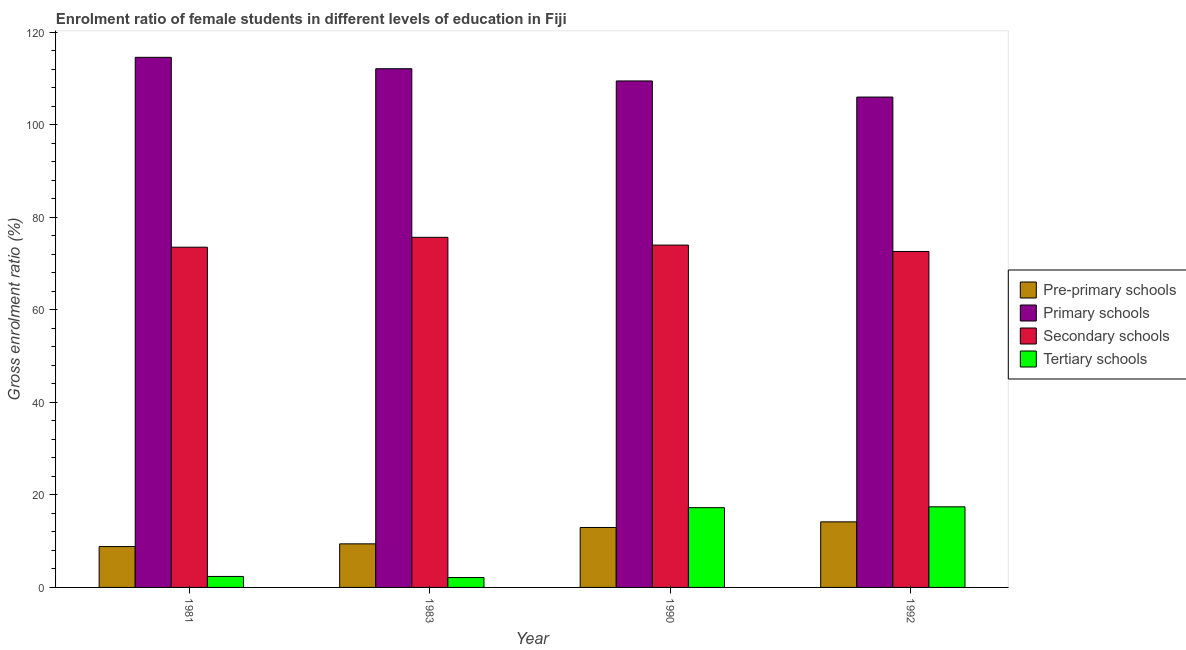How many groups of bars are there?
Your response must be concise. 4. Are the number of bars per tick equal to the number of legend labels?
Ensure brevity in your answer.  Yes. Are the number of bars on each tick of the X-axis equal?
Provide a short and direct response. Yes. How many bars are there on the 3rd tick from the left?
Provide a short and direct response. 4. How many bars are there on the 2nd tick from the right?
Ensure brevity in your answer.  4. In how many cases, is the number of bars for a given year not equal to the number of legend labels?
Your response must be concise. 0. What is the gross enrolment ratio(male) in primary schools in 1983?
Keep it short and to the point. 112.1. Across all years, what is the maximum gross enrolment ratio(male) in secondary schools?
Make the answer very short. 75.66. Across all years, what is the minimum gross enrolment ratio(male) in secondary schools?
Make the answer very short. 72.61. In which year was the gross enrolment ratio(male) in tertiary schools minimum?
Provide a succinct answer. 1983. What is the total gross enrolment ratio(male) in primary schools in the graph?
Provide a succinct answer. 442.09. What is the difference between the gross enrolment ratio(male) in tertiary schools in 1983 and that in 1990?
Offer a terse response. -15.1. What is the difference between the gross enrolment ratio(male) in secondary schools in 1981 and the gross enrolment ratio(male) in tertiary schools in 1983?
Offer a terse response. -2.13. What is the average gross enrolment ratio(male) in tertiary schools per year?
Provide a short and direct response. 9.79. In how many years, is the gross enrolment ratio(male) in secondary schools greater than 108 %?
Make the answer very short. 0. What is the ratio of the gross enrolment ratio(male) in pre-primary schools in 1983 to that in 1990?
Provide a succinct answer. 0.73. Is the gross enrolment ratio(male) in secondary schools in 1981 less than that in 1983?
Provide a succinct answer. Yes. Is the difference between the gross enrolment ratio(male) in secondary schools in 1981 and 1983 greater than the difference between the gross enrolment ratio(male) in tertiary schools in 1981 and 1983?
Your answer should be compact. No. What is the difference between the highest and the second highest gross enrolment ratio(male) in tertiary schools?
Offer a very short reply. 0.19. What is the difference between the highest and the lowest gross enrolment ratio(male) in tertiary schools?
Your answer should be compact. 15.29. In how many years, is the gross enrolment ratio(male) in primary schools greater than the average gross enrolment ratio(male) in primary schools taken over all years?
Offer a terse response. 2. Is the sum of the gross enrolment ratio(male) in pre-primary schools in 1981 and 1983 greater than the maximum gross enrolment ratio(male) in tertiary schools across all years?
Offer a terse response. Yes. What does the 1st bar from the left in 1981 represents?
Give a very brief answer. Pre-primary schools. What does the 4th bar from the right in 1981 represents?
Keep it short and to the point. Pre-primary schools. Is it the case that in every year, the sum of the gross enrolment ratio(male) in pre-primary schools and gross enrolment ratio(male) in primary schools is greater than the gross enrolment ratio(male) in secondary schools?
Ensure brevity in your answer.  Yes. How many years are there in the graph?
Ensure brevity in your answer.  4. Are the values on the major ticks of Y-axis written in scientific E-notation?
Give a very brief answer. No. Does the graph contain any zero values?
Offer a very short reply. No. How are the legend labels stacked?
Offer a very short reply. Vertical. What is the title of the graph?
Make the answer very short. Enrolment ratio of female students in different levels of education in Fiji. What is the label or title of the X-axis?
Your answer should be compact. Year. What is the Gross enrolment ratio (%) in Pre-primary schools in 1981?
Your response must be concise. 8.83. What is the Gross enrolment ratio (%) of Primary schools in 1981?
Provide a succinct answer. 114.56. What is the Gross enrolment ratio (%) of Secondary schools in 1981?
Make the answer very short. 73.53. What is the Gross enrolment ratio (%) in Tertiary schools in 1981?
Provide a short and direct response. 2.37. What is the Gross enrolment ratio (%) of Pre-primary schools in 1983?
Your answer should be compact. 9.42. What is the Gross enrolment ratio (%) in Primary schools in 1983?
Offer a very short reply. 112.1. What is the Gross enrolment ratio (%) in Secondary schools in 1983?
Provide a short and direct response. 75.66. What is the Gross enrolment ratio (%) of Tertiary schools in 1983?
Offer a very short reply. 2.13. What is the Gross enrolment ratio (%) of Pre-primary schools in 1990?
Give a very brief answer. 12.96. What is the Gross enrolment ratio (%) in Primary schools in 1990?
Make the answer very short. 109.46. What is the Gross enrolment ratio (%) of Secondary schools in 1990?
Offer a terse response. 73.99. What is the Gross enrolment ratio (%) in Tertiary schools in 1990?
Your answer should be very brief. 17.23. What is the Gross enrolment ratio (%) of Pre-primary schools in 1992?
Give a very brief answer. 14.17. What is the Gross enrolment ratio (%) in Primary schools in 1992?
Offer a very short reply. 105.98. What is the Gross enrolment ratio (%) in Secondary schools in 1992?
Make the answer very short. 72.61. What is the Gross enrolment ratio (%) in Tertiary schools in 1992?
Your answer should be very brief. 17.42. Across all years, what is the maximum Gross enrolment ratio (%) of Pre-primary schools?
Give a very brief answer. 14.17. Across all years, what is the maximum Gross enrolment ratio (%) in Primary schools?
Provide a short and direct response. 114.56. Across all years, what is the maximum Gross enrolment ratio (%) in Secondary schools?
Offer a very short reply. 75.66. Across all years, what is the maximum Gross enrolment ratio (%) in Tertiary schools?
Your answer should be very brief. 17.42. Across all years, what is the minimum Gross enrolment ratio (%) of Pre-primary schools?
Your response must be concise. 8.83. Across all years, what is the minimum Gross enrolment ratio (%) of Primary schools?
Provide a short and direct response. 105.98. Across all years, what is the minimum Gross enrolment ratio (%) in Secondary schools?
Offer a very short reply. 72.61. Across all years, what is the minimum Gross enrolment ratio (%) in Tertiary schools?
Your answer should be very brief. 2.13. What is the total Gross enrolment ratio (%) of Pre-primary schools in the graph?
Offer a very short reply. 45.37. What is the total Gross enrolment ratio (%) in Primary schools in the graph?
Give a very brief answer. 442.09. What is the total Gross enrolment ratio (%) of Secondary schools in the graph?
Your answer should be compact. 295.78. What is the total Gross enrolment ratio (%) in Tertiary schools in the graph?
Offer a very short reply. 39.16. What is the difference between the Gross enrolment ratio (%) of Pre-primary schools in 1981 and that in 1983?
Make the answer very short. -0.59. What is the difference between the Gross enrolment ratio (%) of Primary schools in 1981 and that in 1983?
Keep it short and to the point. 2.46. What is the difference between the Gross enrolment ratio (%) in Secondary schools in 1981 and that in 1983?
Your answer should be very brief. -2.13. What is the difference between the Gross enrolment ratio (%) of Tertiary schools in 1981 and that in 1983?
Provide a short and direct response. 0.24. What is the difference between the Gross enrolment ratio (%) in Pre-primary schools in 1981 and that in 1990?
Your answer should be compact. -4.13. What is the difference between the Gross enrolment ratio (%) of Primary schools in 1981 and that in 1990?
Your answer should be very brief. 5.1. What is the difference between the Gross enrolment ratio (%) of Secondary schools in 1981 and that in 1990?
Provide a succinct answer. -0.46. What is the difference between the Gross enrolment ratio (%) of Tertiary schools in 1981 and that in 1990?
Ensure brevity in your answer.  -14.86. What is the difference between the Gross enrolment ratio (%) in Pre-primary schools in 1981 and that in 1992?
Make the answer very short. -5.34. What is the difference between the Gross enrolment ratio (%) in Primary schools in 1981 and that in 1992?
Ensure brevity in your answer.  8.58. What is the difference between the Gross enrolment ratio (%) in Secondary schools in 1981 and that in 1992?
Provide a short and direct response. 0.92. What is the difference between the Gross enrolment ratio (%) of Tertiary schools in 1981 and that in 1992?
Give a very brief answer. -15.05. What is the difference between the Gross enrolment ratio (%) in Pre-primary schools in 1983 and that in 1990?
Keep it short and to the point. -3.54. What is the difference between the Gross enrolment ratio (%) in Primary schools in 1983 and that in 1990?
Give a very brief answer. 2.64. What is the difference between the Gross enrolment ratio (%) in Secondary schools in 1983 and that in 1990?
Your answer should be very brief. 1.68. What is the difference between the Gross enrolment ratio (%) in Tertiary schools in 1983 and that in 1990?
Offer a terse response. -15.1. What is the difference between the Gross enrolment ratio (%) in Pre-primary schools in 1983 and that in 1992?
Make the answer very short. -4.75. What is the difference between the Gross enrolment ratio (%) in Primary schools in 1983 and that in 1992?
Keep it short and to the point. 6.12. What is the difference between the Gross enrolment ratio (%) of Secondary schools in 1983 and that in 1992?
Your answer should be very brief. 3.06. What is the difference between the Gross enrolment ratio (%) of Tertiary schools in 1983 and that in 1992?
Your answer should be very brief. -15.29. What is the difference between the Gross enrolment ratio (%) in Pre-primary schools in 1990 and that in 1992?
Your answer should be very brief. -1.22. What is the difference between the Gross enrolment ratio (%) of Primary schools in 1990 and that in 1992?
Ensure brevity in your answer.  3.48. What is the difference between the Gross enrolment ratio (%) in Secondary schools in 1990 and that in 1992?
Provide a short and direct response. 1.38. What is the difference between the Gross enrolment ratio (%) in Tertiary schools in 1990 and that in 1992?
Your response must be concise. -0.19. What is the difference between the Gross enrolment ratio (%) in Pre-primary schools in 1981 and the Gross enrolment ratio (%) in Primary schools in 1983?
Your response must be concise. -103.27. What is the difference between the Gross enrolment ratio (%) in Pre-primary schools in 1981 and the Gross enrolment ratio (%) in Secondary schools in 1983?
Give a very brief answer. -66.83. What is the difference between the Gross enrolment ratio (%) of Pre-primary schools in 1981 and the Gross enrolment ratio (%) of Tertiary schools in 1983?
Offer a terse response. 6.7. What is the difference between the Gross enrolment ratio (%) of Primary schools in 1981 and the Gross enrolment ratio (%) of Secondary schools in 1983?
Ensure brevity in your answer.  38.9. What is the difference between the Gross enrolment ratio (%) of Primary schools in 1981 and the Gross enrolment ratio (%) of Tertiary schools in 1983?
Give a very brief answer. 112.43. What is the difference between the Gross enrolment ratio (%) of Secondary schools in 1981 and the Gross enrolment ratio (%) of Tertiary schools in 1983?
Your answer should be compact. 71.39. What is the difference between the Gross enrolment ratio (%) of Pre-primary schools in 1981 and the Gross enrolment ratio (%) of Primary schools in 1990?
Offer a terse response. -100.63. What is the difference between the Gross enrolment ratio (%) in Pre-primary schools in 1981 and the Gross enrolment ratio (%) in Secondary schools in 1990?
Offer a very short reply. -65.16. What is the difference between the Gross enrolment ratio (%) of Pre-primary schools in 1981 and the Gross enrolment ratio (%) of Tertiary schools in 1990?
Provide a short and direct response. -8.41. What is the difference between the Gross enrolment ratio (%) of Primary schools in 1981 and the Gross enrolment ratio (%) of Secondary schools in 1990?
Give a very brief answer. 40.57. What is the difference between the Gross enrolment ratio (%) in Primary schools in 1981 and the Gross enrolment ratio (%) in Tertiary schools in 1990?
Offer a very short reply. 97.33. What is the difference between the Gross enrolment ratio (%) of Secondary schools in 1981 and the Gross enrolment ratio (%) of Tertiary schools in 1990?
Ensure brevity in your answer.  56.29. What is the difference between the Gross enrolment ratio (%) in Pre-primary schools in 1981 and the Gross enrolment ratio (%) in Primary schools in 1992?
Make the answer very short. -97.15. What is the difference between the Gross enrolment ratio (%) of Pre-primary schools in 1981 and the Gross enrolment ratio (%) of Secondary schools in 1992?
Offer a very short reply. -63.78. What is the difference between the Gross enrolment ratio (%) of Pre-primary schools in 1981 and the Gross enrolment ratio (%) of Tertiary schools in 1992?
Make the answer very short. -8.59. What is the difference between the Gross enrolment ratio (%) of Primary schools in 1981 and the Gross enrolment ratio (%) of Secondary schools in 1992?
Your answer should be very brief. 41.95. What is the difference between the Gross enrolment ratio (%) in Primary schools in 1981 and the Gross enrolment ratio (%) in Tertiary schools in 1992?
Your answer should be very brief. 97.14. What is the difference between the Gross enrolment ratio (%) of Secondary schools in 1981 and the Gross enrolment ratio (%) of Tertiary schools in 1992?
Provide a short and direct response. 56.11. What is the difference between the Gross enrolment ratio (%) of Pre-primary schools in 1983 and the Gross enrolment ratio (%) of Primary schools in 1990?
Offer a terse response. -100.04. What is the difference between the Gross enrolment ratio (%) in Pre-primary schools in 1983 and the Gross enrolment ratio (%) in Secondary schools in 1990?
Ensure brevity in your answer.  -64.57. What is the difference between the Gross enrolment ratio (%) in Pre-primary schools in 1983 and the Gross enrolment ratio (%) in Tertiary schools in 1990?
Ensure brevity in your answer.  -7.82. What is the difference between the Gross enrolment ratio (%) in Primary schools in 1983 and the Gross enrolment ratio (%) in Secondary schools in 1990?
Offer a very short reply. 38.11. What is the difference between the Gross enrolment ratio (%) in Primary schools in 1983 and the Gross enrolment ratio (%) in Tertiary schools in 1990?
Provide a succinct answer. 94.86. What is the difference between the Gross enrolment ratio (%) of Secondary schools in 1983 and the Gross enrolment ratio (%) of Tertiary schools in 1990?
Offer a terse response. 58.43. What is the difference between the Gross enrolment ratio (%) in Pre-primary schools in 1983 and the Gross enrolment ratio (%) in Primary schools in 1992?
Keep it short and to the point. -96.56. What is the difference between the Gross enrolment ratio (%) of Pre-primary schools in 1983 and the Gross enrolment ratio (%) of Secondary schools in 1992?
Offer a terse response. -63.19. What is the difference between the Gross enrolment ratio (%) in Pre-primary schools in 1983 and the Gross enrolment ratio (%) in Tertiary schools in 1992?
Make the answer very short. -8. What is the difference between the Gross enrolment ratio (%) in Primary schools in 1983 and the Gross enrolment ratio (%) in Secondary schools in 1992?
Your response must be concise. 39.49. What is the difference between the Gross enrolment ratio (%) of Primary schools in 1983 and the Gross enrolment ratio (%) of Tertiary schools in 1992?
Your answer should be compact. 94.68. What is the difference between the Gross enrolment ratio (%) in Secondary schools in 1983 and the Gross enrolment ratio (%) in Tertiary schools in 1992?
Give a very brief answer. 58.24. What is the difference between the Gross enrolment ratio (%) in Pre-primary schools in 1990 and the Gross enrolment ratio (%) in Primary schools in 1992?
Ensure brevity in your answer.  -93.02. What is the difference between the Gross enrolment ratio (%) in Pre-primary schools in 1990 and the Gross enrolment ratio (%) in Secondary schools in 1992?
Offer a terse response. -59.65. What is the difference between the Gross enrolment ratio (%) of Pre-primary schools in 1990 and the Gross enrolment ratio (%) of Tertiary schools in 1992?
Your answer should be compact. -4.46. What is the difference between the Gross enrolment ratio (%) in Primary schools in 1990 and the Gross enrolment ratio (%) in Secondary schools in 1992?
Your answer should be very brief. 36.85. What is the difference between the Gross enrolment ratio (%) in Primary schools in 1990 and the Gross enrolment ratio (%) in Tertiary schools in 1992?
Make the answer very short. 92.04. What is the difference between the Gross enrolment ratio (%) of Secondary schools in 1990 and the Gross enrolment ratio (%) of Tertiary schools in 1992?
Make the answer very short. 56.57. What is the average Gross enrolment ratio (%) in Pre-primary schools per year?
Make the answer very short. 11.34. What is the average Gross enrolment ratio (%) of Primary schools per year?
Provide a succinct answer. 110.52. What is the average Gross enrolment ratio (%) of Secondary schools per year?
Offer a very short reply. 73.94. What is the average Gross enrolment ratio (%) of Tertiary schools per year?
Provide a short and direct response. 9.79. In the year 1981, what is the difference between the Gross enrolment ratio (%) of Pre-primary schools and Gross enrolment ratio (%) of Primary schools?
Ensure brevity in your answer.  -105.73. In the year 1981, what is the difference between the Gross enrolment ratio (%) in Pre-primary schools and Gross enrolment ratio (%) in Secondary schools?
Provide a short and direct response. -64.7. In the year 1981, what is the difference between the Gross enrolment ratio (%) in Pre-primary schools and Gross enrolment ratio (%) in Tertiary schools?
Your answer should be compact. 6.46. In the year 1981, what is the difference between the Gross enrolment ratio (%) in Primary schools and Gross enrolment ratio (%) in Secondary schools?
Your response must be concise. 41.03. In the year 1981, what is the difference between the Gross enrolment ratio (%) of Primary schools and Gross enrolment ratio (%) of Tertiary schools?
Make the answer very short. 112.19. In the year 1981, what is the difference between the Gross enrolment ratio (%) of Secondary schools and Gross enrolment ratio (%) of Tertiary schools?
Give a very brief answer. 71.15. In the year 1983, what is the difference between the Gross enrolment ratio (%) of Pre-primary schools and Gross enrolment ratio (%) of Primary schools?
Provide a succinct answer. -102.68. In the year 1983, what is the difference between the Gross enrolment ratio (%) of Pre-primary schools and Gross enrolment ratio (%) of Secondary schools?
Your response must be concise. -66.24. In the year 1983, what is the difference between the Gross enrolment ratio (%) of Pre-primary schools and Gross enrolment ratio (%) of Tertiary schools?
Give a very brief answer. 7.28. In the year 1983, what is the difference between the Gross enrolment ratio (%) in Primary schools and Gross enrolment ratio (%) in Secondary schools?
Provide a succinct answer. 36.44. In the year 1983, what is the difference between the Gross enrolment ratio (%) in Primary schools and Gross enrolment ratio (%) in Tertiary schools?
Provide a succinct answer. 109.97. In the year 1983, what is the difference between the Gross enrolment ratio (%) in Secondary schools and Gross enrolment ratio (%) in Tertiary schools?
Provide a short and direct response. 73.53. In the year 1990, what is the difference between the Gross enrolment ratio (%) of Pre-primary schools and Gross enrolment ratio (%) of Primary schools?
Make the answer very short. -96.5. In the year 1990, what is the difference between the Gross enrolment ratio (%) in Pre-primary schools and Gross enrolment ratio (%) in Secondary schools?
Your response must be concise. -61.03. In the year 1990, what is the difference between the Gross enrolment ratio (%) in Pre-primary schools and Gross enrolment ratio (%) in Tertiary schools?
Your answer should be compact. -4.28. In the year 1990, what is the difference between the Gross enrolment ratio (%) in Primary schools and Gross enrolment ratio (%) in Secondary schools?
Offer a terse response. 35.47. In the year 1990, what is the difference between the Gross enrolment ratio (%) of Primary schools and Gross enrolment ratio (%) of Tertiary schools?
Keep it short and to the point. 92.22. In the year 1990, what is the difference between the Gross enrolment ratio (%) in Secondary schools and Gross enrolment ratio (%) in Tertiary schools?
Your response must be concise. 56.75. In the year 1992, what is the difference between the Gross enrolment ratio (%) in Pre-primary schools and Gross enrolment ratio (%) in Primary schools?
Provide a short and direct response. -91.8. In the year 1992, what is the difference between the Gross enrolment ratio (%) of Pre-primary schools and Gross enrolment ratio (%) of Secondary schools?
Ensure brevity in your answer.  -58.43. In the year 1992, what is the difference between the Gross enrolment ratio (%) in Pre-primary schools and Gross enrolment ratio (%) in Tertiary schools?
Make the answer very short. -3.25. In the year 1992, what is the difference between the Gross enrolment ratio (%) in Primary schools and Gross enrolment ratio (%) in Secondary schools?
Keep it short and to the point. 33.37. In the year 1992, what is the difference between the Gross enrolment ratio (%) in Primary schools and Gross enrolment ratio (%) in Tertiary schools?
Offer a terse response. 88.56. In the year 1992, what is the difference between the Gross enrolment ratio (%) of Secondary schools and Gross enrolment ratio (%) of Tertiary schools?
Provide a short and direct response. 55.19. What is the ratio of the Gross enrolment ratio (%) in Pre-primary schools in 1981 to that in 1983?
Offer a very short reply. 0.94. What is the ratio of the Gross enrolment ratio (%) of Secondary schools in 1981 to that in 1983?
Keep it short and to the point. 0.97. What is the ratio of the Gross enrolment ratio (%) of Tertiary schools in 1981 to that in 1983?
Make the answer very short. 1.11. What is the ratio of the Gross enrolment ratio (%) in Pre-primary schools in 1981 to that in 1990?
Your answer should be very brief. 0.68. What is the ratio of the Gross enrolment ratio (%) in Primary schools in 1981 to that in 1990?
Your answer should be very brief. 1.05. What is the ratio of the Gross enrolment ratio (%) in Secondary schools in 1981 to that in 1990?
Provide a short and direct response. 0.99. What is the ratio of the Gross enrolment ratio (%) in Tertiary schools in 1981 to that in 1990?
Offer a very short reply. 0.14. What is the ratio of the Gross enrolment ratio (%) of Pre-primary schools in 1981 to that in 1992?
Provide a succinct answer. 0.62. What is the ratio of the Gross enrolment ratio (%) of Primary schools in 1981 to that in 1992?
Offer a terse response. 1.08. What is the ratio of the Gross enrolment ratio (%) of Secondary schools in 1981 to that in 1992?
Ensure brevity in your answer.  1.01. What is the ratio of the Gross enrolment ratio (%) of Tertiary schools in 1981 to that in 1992?
Offer a very short reply. 0.14. What is the ratio of the Gross enrolment ratio (%) of Pre-primary schools in 1983 to that in 1990?
Ensure brevity in your answer.  0.73. What is the ratio of the Gross enrolment ratio (%) in Primary schools in 1983 to that in 1990?
Provide a short and direct response. 1.02. What is the ratio of the Gross enrolment ratio (%) of Secondary schools in 1983 to that in 1990?
Ensure brevity in your answer.  1.02. What is the ratio of the Gross enrolment ratio (%) in Tertiary schools in 1983 to that in 1990?
Your response must be concise. 0.12. What is the ratio of the Gross enrolment ratio (%) of Pre-primary schools in 1983 to that in 1992?
Offer a terse response. 0.66. What is the ratio of the Gross enrolment ratio (%) of Primary schools in 1983 to that in 1992?
Give a very brief answer. 1.06. What is the ratio of the Gross enrolment ratio (%) in Secondary schools in 1983 to that in 1992?
Your response must be concise. 1.04. What is the ratio of the Gross enrolment ratio (%) in Tertiary schools in 1983 to that in 1992?
Ensure brevity in your answer.  0.12. What is the ratio of the Gross enrolment ratio (%) in Pre-primary schools in 1990 to that in 1992?
Your answer should be very brief. 0.91. What is the ratio of the Gross enrolment ratio (%) of Primary schools in 1990 to that in 1992?
Provide a short and direct response. 1.03. What is the ratio of the Gross enrolment ratio (%) of Secondary schools in 1990 to that in 1992?
Your answer should be compact. 1.02. What is the difference between the highest and the second highest Gross enrolment ratio (%) of Pre-primary schools?
Provide a succinct answer. 1.22. What is the difference between the highest and the second highest Gross enrolment ratio (%) in Primary schools?
Ensure brevity in your answer.  2.46. What is the difference between the highest and the second highest Gross enrolment ratio (%) of Secondary schools?
Ensure brevity in your answer.  1.68. What is the difference between the highest and the second highest Gross enrolment ratio (%) of Tertiary schools?
Make the answer very short. 0.19. What is the difference between the highest and the lowest Gross enrolment ratio (%) of Pre-primary schools?
Provide a short and direct response. 5.34. What is the difference between the highest and the lowest Gross enrolment ratio (%) of Primary schools?
Your answer should be very brief. 8.58. What is the difference between the highest and the lowest Gross enrolment ratio (%) in Secondary schools?
Give a very brief answer. 3.06. What is the difference between the highest and the lowest Gross enrolment ratio (%) of Tertiary schools?
Your answer should be very brief. 15.29. 